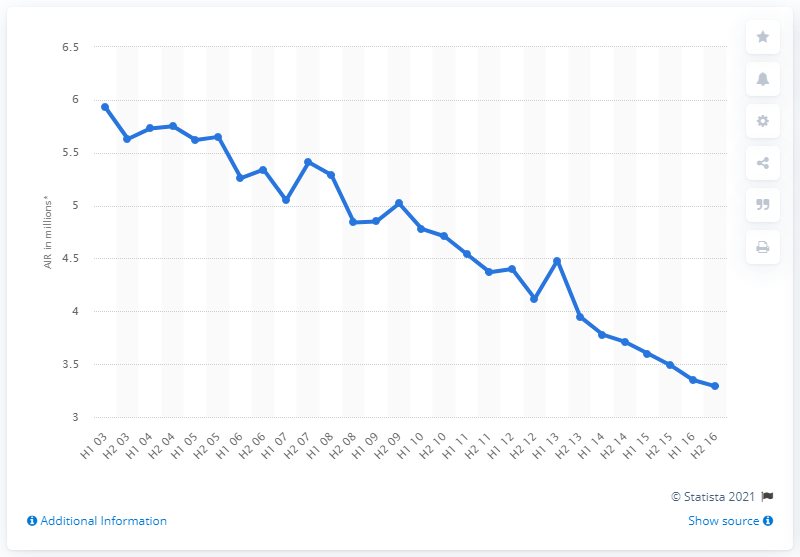Specify some key components in this picture. According to data from July to December 2015, the average readership per issue of the Daily Mail was 3.49. 